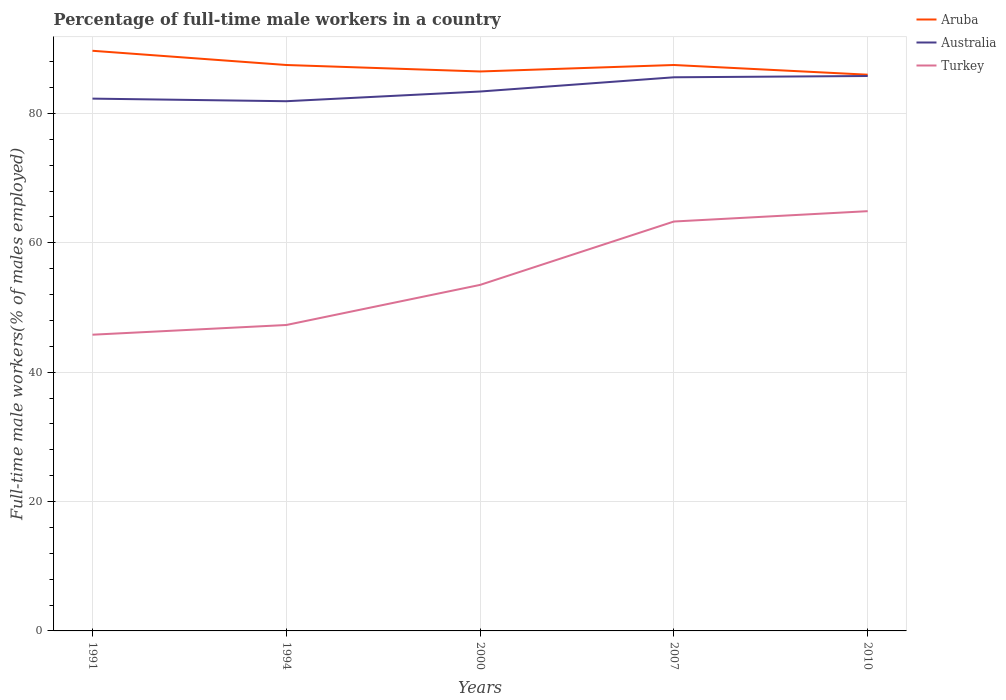Does the line corresponding to Aruba intersect with the line corresponding to Turkey?
Provide a short and direct response. No. Is the number of lines equal to the number of legend labels?
Offer a very short reply. Yes. Across all years, what is the maximum percentage of full-time male workers in Australia?
Your answer should be compact. 81.9. What is the total percentage of full-time male workers in Aruba in the graph?
Make the answer very short. 1.5. What is the difference between the highest and the second highest percentage of full-time male workers in Aruba?
Provide a short and direct response. 3.7. What is the difference between the highest and the lowest percentage of full-time male workers in Turkey?
Make the answer very short. 2. Is the percentage of full-time male workers in Australia strictly greater than the percentage of full-time male workers in Aruba over the years?
Your answer should be compact. Yes. How many lines are there?
Keep it short and to the point. 3. How many years are there in the graph?
Provide a succinct answer. 5. What is the difference between two consecutive major ticks on the Y-axis?
Offer a terse response. 20. Are the values on the major ticks of Y-axis written in scientific E-notation?
Give a very brief answer. No. Does the graph contain any zero values?
Give a very brief answer. No. Where does the legend appear in the graph?
Offer a terse response. Top right. How many legend labels are there?
Provide a short and direct response. 3. What is the title of the graph?
Provide a short and direct response. Percentage of full-time male workers in a country. What is the label or title of the Y-axis?
Provide a succinct answer. Full-time male workers(% of males employed). What is the Full-time male workers(% of males employed) of Aruba in 1991?
Provide a succinct answer. 89.7. What is the Full-time male workers(% of males employed) in Australia in 1991?
Make the answer very short. 82.3. What is the Full-time male workers(% of males employed) of Turkey in 1991?
Provide a succinct answer. 45.8. What is the Full-time male workers(% of males employed) of Aruba in 1994?
Your answer should be compact. 87.5. What is the Full-time male workers(% of males employed) in Australia in 1994?
Your answer should be very brief. 81.9. What is the Full-time male workers(% of males employed) in Turkey in 1994?
Ensure brevity in your answer.  47.3. What is the Full-time male workers(% of males employed) of Aruba in 2000?
Your answer should be very brief. 86.5. What is the Full-time male workers(% of males employed) in Australia in 2000?
Keep it short and to the point. 83.4. What is the Full-time male workers(% of males employed) in Turkey in 2000?
Your response must be concise. 53.5. What is the Full-time male workers(% of males employed) in Aruba in 2007?
Offer a very short reply. 87.5. What is the Full-time male workers(% of males employed) of Australia in 2007?
Give a very brief answer. 85.6. What is the Full-time male workers(% of males employed) in Turkey in 2007?
Provide a succinct answer. 63.3. What is the Full-time male workers(% of males employed) of Australia in 2010?
Make the answer very short. 85.8. What is the Full-time male workers(% of males employed) of Turkey in 2010?
Make the answer very short. 64.9. Across all years, what is the maximum Full-time male workers(% of males employed) in Aruba?
Provide a short and direct response. 89.7. Across all years, what is the maximum Full-time male workers(% of males employed) of Australia?
Provide a short and direct response. 85.8. Across all years, what is the maximum Full-time male workers(% of males employed) of Turkey?
Offer a very short reply. 64.9. Across all years, what is the minimum Full-time male workers(% of males employed) of Aruba?
Your answer should be very brief. 86. Across all years, what is the minimum Full-time male workers(% of males employed) of Australia?
Your answer should be compact. 81.9. Across all years, what is the minimum Full-time male workers(% of males employed) in Turkey?
Ensure brevity in your answer.  45.8. What is the total Full-time male workers(% of males employed) of Aruba in the graph?
Offer a very short reply. 437.2. What is the total Full-time male workers(% of males employed) in Australia in the graph?
Offer a very short reply. 419. What is the total Full-time male workers(% of males employed) in Turkey in the graph?
Your answer should be compact. 274.8. What is the difference between the Full-time male workers(% of males employed) in Australia in 1991 and that in 1994?
Make the answer very short. 0.4. What is the difference between the Full-time male workers(% of males employed) of Aruba in 1991 and that in 2000?
Your answer should be compact. 3.2. What is the difference between the Full-time male workers(% of males employed) in Aruba in 1991 and that in 2007?
Give a very brief answer. 2.2. What is the difference between the Full-time male workers(% of males employed) in Australia in 1991 and that in 2007?
Your answer should be compact. -3.3. What is the difference between the Full-time male workers(% of males employed) of Turkey in 1991 and that in 2007?
Provide a short and direct response. -17.5. What is the difference between the Full-time male workers(% of males employed) in Aruba in 1991 and that in 2010?
Your answer should be very brief. 3.7. What is the difference between the Full-time male workers(% of males employed) of Australia in 1991 and that in 2010?
Your answer should be compact. -3.5. What is the difference between the Full-time male workers(% of males employed) in Turkey in 1991 and that in 2010?
Your response must be concise. -19.1. What is the difference between the Full-time male workers(% of males employed) of Aruba in 1994 and that in 2000?
Provide a succinct answer. 1. What is the difference between the Full-time male workers(% of males employed) of Australia in 1994 and that in 2000?
Keep it short and to the point. -1.5. What is the difference between the Full-time male workers(% of males employed) in Aruba in 1994 and that in 2007?
Offer a terse response. 0. What is the difference between the Full-time male workers(% of males employed) in Turkey in 1994 and that in 2007?
Ensure brevity in your answer.  -16. What is the difference between the Full-time male workers(% of males employed) of Turkey in 1994 and that in 2010?
Your answer should be compact. -17.6. What is the difference between the Full-time male workers(% of males employed) of Australia in 2000 and that in 2007?
Provide a short and direct response. -2.2. What is the difference between the Full-time male workers(% of males employed) of Turkey in 2000 and that in 2007?
Your answer should be very brief. -9.8. What is the difference between the Full-time male workers(% of males employed) of Turkey in 2007 and that in 2010?
Offer a terse response. -1.6. What is the difference between the Full-time male workers(% of males employed) in Aruba in 1991 and the Full-time male workers(% of males employed) in Australia in 1994?
Your answer should be very brief. 7.8. What is the difference between the Full-time male workers(% of males employed) in Aruba in 1991 and the Full-time male workers(% of males employed) in Turkey in 1994?
Offer a terse response. 42.4. What is the difference between the Full-time male workers(% of males employed) of Australia in 1991 and the Full-time male workers(% of males employed) of Turkey in 1994?
Your response must be concise. 35. What is the difference between the Full-time male workers(% of males employed) of Aruba in 1991 and the Full-time male workers(% of males employed) of Australia in 2000?
Your answer should be compact. 6.3. What is the difference between the Full-time male workers(% of males employed) in Aruba in 1991 and the Full-time male workers(% of males employed) in Turkey in 2000?
Give a very brief answer. 36.2. What is the difference between the Full-time male workers(% of males employed) of Australia in 1991 and the Full-time male workers(% of males employed) of Turkey in 2000?
Your response must be concise. 28.8. What is the difference between the Full-time male workers(% of males employed) in Aruba in 1991 and the Full-time male workers(% of males employed) in Turkey in 2007?
Provide a succinct answer. 26.4. What is the difference between the Full-time male workers(% of males employed) in Australia in 1991 and the Full-time male workers(% of males employed) in Turkey in 2007?
Offer a very short reply. 19. What is the difference between the Full-time male workers(% of males employed) in Aruba in 1991 and the Full-time male workers(% of males employed) in Turkey in 2010?
Your answer should be compact. 24.8. What is the difference between the Full-time male workers(% of males employed) in Australia in 1991 and the Full-time male workers(% of males employed) in Turkey in 2010?
Give a very brief answer. 17.4. What is the difference between the Full-time male workers(% of males employed) of Aruba in 1994 and the Full-time male workers(% of males employed) of Australia in 2000?
Make the answer very short. 4.1. What is the difference between the Full-time male workers(% of males employed) of Australia in 1994 and the Full-time male workers(% of males employed) of Turkey in 2000?
Offer a terse response. 28.4. What is the difference between the Full-time male workers(% of males employed) of Aruba in 1994 and the Full-time male workers(% of males employed) of Australia in 2007?
Your answer should be compact. 1.9. What is the difference between the Full-time male workers(% of males employed) of Aruba in 1994 and the Full-time male workers(% of males employed) of Turkey in 2007?
Provide a succinct answer. 24.2. What is the difference between the Full-time male workers(% of males employed) in Australia in 1994 and the Full-time male workers(% of males employed) in Turkey in 2007?
Give a very brief answer. 18.6. What is the difference between the Full-time male workers(% of males employed) in Aruba in 1994 and the Full-time male workers(% of males employed) in Australia in 2010?
Give a very brief answer. 1.7. What is the difference between the Full-time male workers(% of males employed) of Aruba in 1994 and the Full-time male workers(% of males employed) of Turkey in 2010?
Ensure brevity in your answer.  22.6. What is the difference between the Full-time male workers(% of males employed) in Aruba in 2000 and the Full-time male workers(% of males employed) in Australia in 2007?
Your answer should be compact. 0.9. What is the difference between the Full-time male workers(% of males employed) of Aruba in 2000 and the Full-time male workers(% of males employed) of Turkey in 2007?
Provide a short and direct response. 23.2. What is the difference between the Full-time male workers(% of males employed) of Australia in 2000 and the Full-time male workers(% of males employed) of Turkey in 2007?
Your response must be concise. 20.1. What is the difference between the Full-time male workers(% of males employed) of Aruba in 2000 and the Full-time male workers(% of males employed) of Turkey in 2010?
Give a very brief answer. 21.6. What is the difference between the Full-time male workers(% of males employed) of Australia in 2000 and the Full-time male workers(% of males employed) of Turkey in 2010?
Offer a terse response. 18.5. What is the difference between the Full-time male workers(% of males employed) of Aruba in 2007 and the Full-time male workers(% of males employed) of Australia in 2010?
Your answer should be compact. 1.7. What is the difference between the Full-time male workers(% of males employed) of Aruba in 2007 and the Full-time male workers(% of males employed) of Turkey in 2010?
Provide a short and direct response. 22.6. What is the difference between the Full-time male workers(% of males employed) of Australia in 2007 and the Full-time male workers(% of males employed) of Turkey in 2010?
Offer a terse response. 20.7. What is the average Full-time male workers(% of males employed) of Aruba per year?
Ensure brevity in your answer.  87.44. What is the average Full-time male workers(% of males employed) in Australia per year?
Keep it short and to the point. 83.8. What is the average Full-time male workers(% of males employed) in Turkey per year?
Offer a very short reply. 54.96. In the year 1991, what is the difference between the Full-time male workers(% of males employed) of Aruba and Full-time male workers(% of males employed) of Australia?
Offer a very short reply. 7.4. In the year 1991, what is the difference between the Full-time male workers(% of males employed) in Aruba and Full-time male workers(% of males employed) in Turkey?
Make the answer very short. 43.9. In the year 1991, what is the difference between the Full-time male workers(% of males employed) of Australia and Full-time male workers(% of males employed) of Turkey?
Offer a terse response. 36.5. In the year 1994, what is the difference between the Full-time male workers(% of males employed) of Aruba and Full-time male workers(% of males employed) of Turkey?
Provide a succinct answer. 40.2. In the year 1994, what is the difference between the Full-time male workers(% of males employed) of Australia and Full-time male workers(% of males employed) of Turkey?
Your response must be concise. 34.6. In the year 2000, what is the difference between the Full-time male workers(% of males employed) of Australia and Full-time male workers(% of males employed) of Turkey?
Give a very brief answer. 29.9. In the year 2007, what is the difference between the Full-time male workers(% of males employed) in Aruba and Full-time male workers(% of males employed) in Turkey?
Give a very brief answer. 24.2. In the year 2007, what is the difference between the Full-time male workers(% of males employed) in Australia and Full-time male workers(% of males employed) in Turkey?
Make the answer very short. 22.3. In the year 2010, what is the difference between the Full-time male workers(% of males employed) of Aruba and Full-time male workers(% of males employed) of Turkey?
Ensure brevity in your answer.  21.1. In the year 2010, what is the difference between the Full-time male workers(% of males employed) of Australia and Full-time male workers(% of males employed) of Turkey?
Ensure brevity in your answer.  20.9. What is the ratio of the Full-time male workers(% of males employed) in Aruba in 1991 to that in 1994?
Offer a very short reply. 1.03. What is the ratio of the Full-time male workers(% of males employed) of Turkey in 1991 to that in 1994?
Your answer should be very brief. 0.97. What is the ratio of the Full-time male workers(% of males employed) in Aruba in 1991 to that in 2000?
Give a very brief answer. 1.04. What is the ratio of the Full-time male workers(% of males employed) of Australia in 1991 to that in 2000?
Offer a very short reply. 0.99. What is the ratio of the Full-time male workers(% of males employed) of Turkey in 1991 to that in 2000?
Your answer should be very brief. 0.86. What is the ratio of the Full-time male workers(% of males employed) in Aruba in 1991 to that in 2007?
Offer a terse response. 1.03. What is the ratio of the Full-time male workers(% of males employed) of Australia in 1991 to that in 2007?
Offer a terse response. 0.96. What is the ratio of the Full-time male workers(% of males employed) of Turkey in 1991 to that in 2007?
Make the answer very short. 0.72. What is the ratio of the Full-time male workers(% of males employed) in Aruba in 1991 to that in 2010?
Your response must be concise. 1.04. What is the ratio of the Full-time male workers(% of males employed) in Australia in 1991 to that in 2010?
Keep it short and to the point. 0.96. What is the ratio of the Full-time male workers(% of males employed) in Turkey in 1991 to that in 2010?
Offer a terse response. 0.71. What is the ratio of the Full-time male workers(% of males employed) of Aruba in 1994 to that in 2000?
Ensure brevity in your answer.  1.01. What is the ratio of the Full-time male workers(% of males employed) in Turkey in 1994 to that in 2000?
Keep it short and to the point. 0.88. What is the ratio of the Full-time male workers(% of males employed) of Aruba in 1994 to that in 2007?
Provide a short and direct response. 1. What is the ratio of the Full-time male workers(% of males employed) of Australia in 1994 to that in 2007?
Provide a succinct answer. 0.96. What is the ratio of the Full-time male workers(% of males employed) in Turkey in 1994 to that in 2007?
Offer a very short reply. 0.75. What is the ratio of the Full-time male workers(% of males employed) of Aruba in 1994 to that in 2010?
Give a very brief answer. 1.02. What is the ratio of the Full-time male workers(% of males employed) in Australia in 1994 to that in 2010?
Give a very brief answer. 0.95. What is the ratio of the Full-time male workers(% of males employed) of Turkey in 1994 to that in 2010?
Keep it short and to the point. 0.73. What is the ratio of the Full-time male workers(% of males employed) in Australia in 2000 to that in 2007?
Your response must be concise. 0.97. What is the ratio of the Full-time male workers(% of males employed) in Turkey in 2000 to that in 2007?
Provide a succinct answer. 0.85. What is the ratio of the Full-time male workers(% of males employed) in Aruba in 2000 to that in 2010?
Offer a terse response. 1.01. What is the ratio of the Full-time male workers(% of males employed) of Australia in 2000 to that in 2010?
Your answer should be compact. 0.97. What is the ratio of the Full-time male workers(% of males employed) of Turkey in 2000 to that in 2010?
Your response must be concise. 0.82. What is the ratio of the Full-time male workers(% of males employed) of Aruba in 2007 to that in 2010?
Your response must be concise. 1.02. What is the ratio of the Full-time male workers(% of males employed) of Australia in 2007 to that in 2010?
Your answer should be very brief. 1. What is the ratio of the Full-time male workers(% of males employed) in Turkey in 2007 to that in 2010?
Provide a succinct answer. 0.98. What is the difference between the highest and the second highest Full-time male workers(% of males employed) in Aruba?
Ensure brevity in your answer.  2.2. What is the difference between the highest and the lowest Full-time male workers(% of males employed) of Australia?
Your response must be concise. 3.9. 